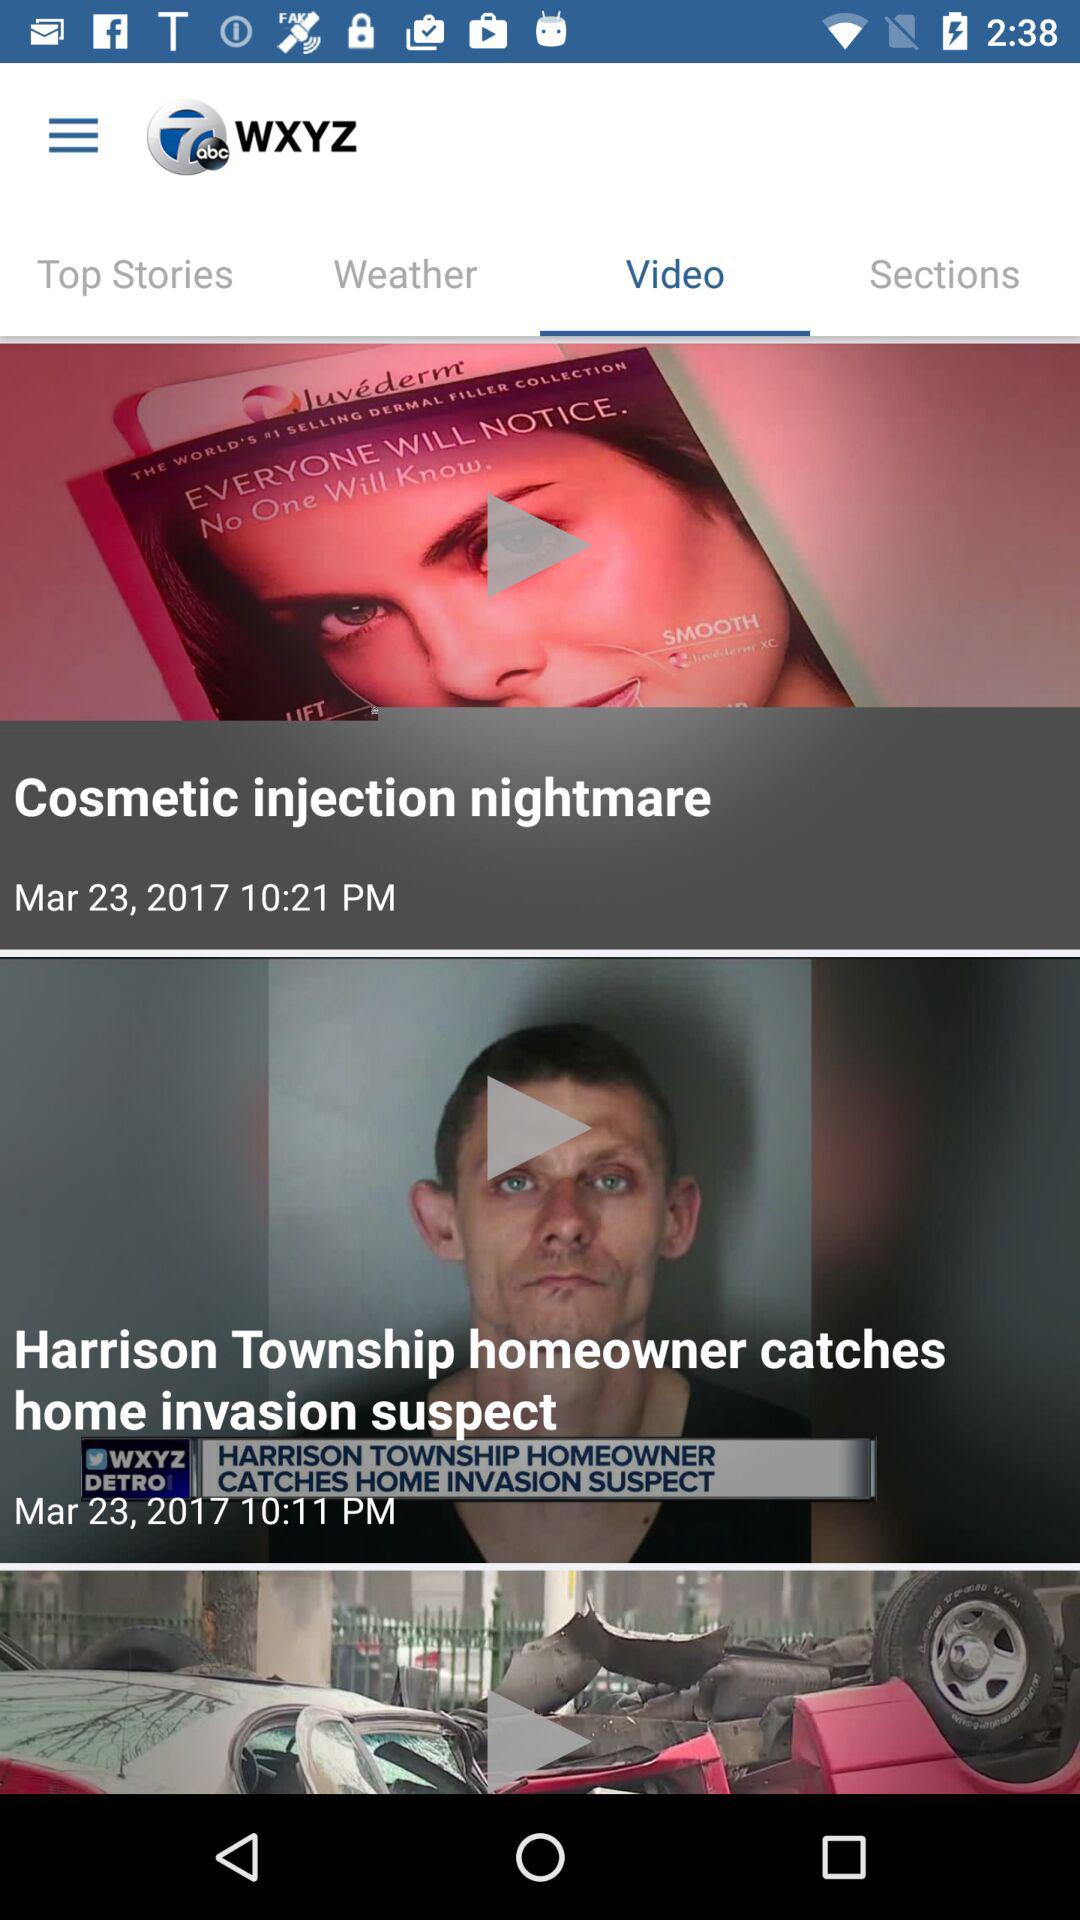When was the video "Cosmetic injection nightmare" published? The video "Cosmetic injection nightmare" was published on March 23, 2017 at 10:21 p.m. 